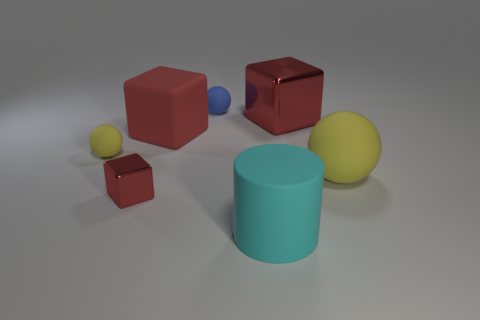Do the tiny rubber ball left of the tiny red shiny object and the cylinder have the same color?
Provide a short and direct response. No. What number of objects are either cyan matte balls or matte spheres?
Offer a very short reply. 3. Is the size of the red metal object left of the cyan rubber cylinder the same as the tiny blue thing?
Ensure brevity in your answer.  Yes. How big is the ball that is in front of the big metal object and to the right of the small yellow sphere?
Offer a very short reply. Large. How many other objects are there of the same shape as the large cyan object?
Offer a very short reply. 0. What number of other things are made of the same material as the cyan thing?
Give a very brief answer. 4. The blue thing that is the same shape as the big yellow thing is what size?
Your answer should be compact. Small. Is the big matte cube the same color as the tiny shiny thing?
Make the answer very short. Yes. There is a block that is left of the cyan object and behind the small red metal object; what color is it?
Your answer should be very brief. Red. What number of things are either metallic blocks that are right of the tiny blue ball or yellow things?
Your response must be concise. 3. 